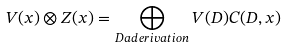Convert formula to latex. <formula><loc_0><loc_0><loc_500><loc_500>V ( x ) \otimes Z ( x ) = \bigoplus _ { D a d e r i v a t i o n } V ( D ) C ( D , x )</formula> 